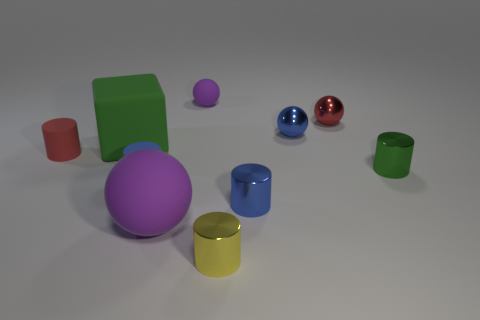How many unique shapes can you identify in the scene? I can identify four unique shapes in this scene: a sphere, a cylinder, a cube, and a cone. Are any of the shapes repeated in different colors? Yes, the sphere and cylinder shapes are repeated, each appearing in different colors. The spheres, for instance, come in purple, blue, and red. 